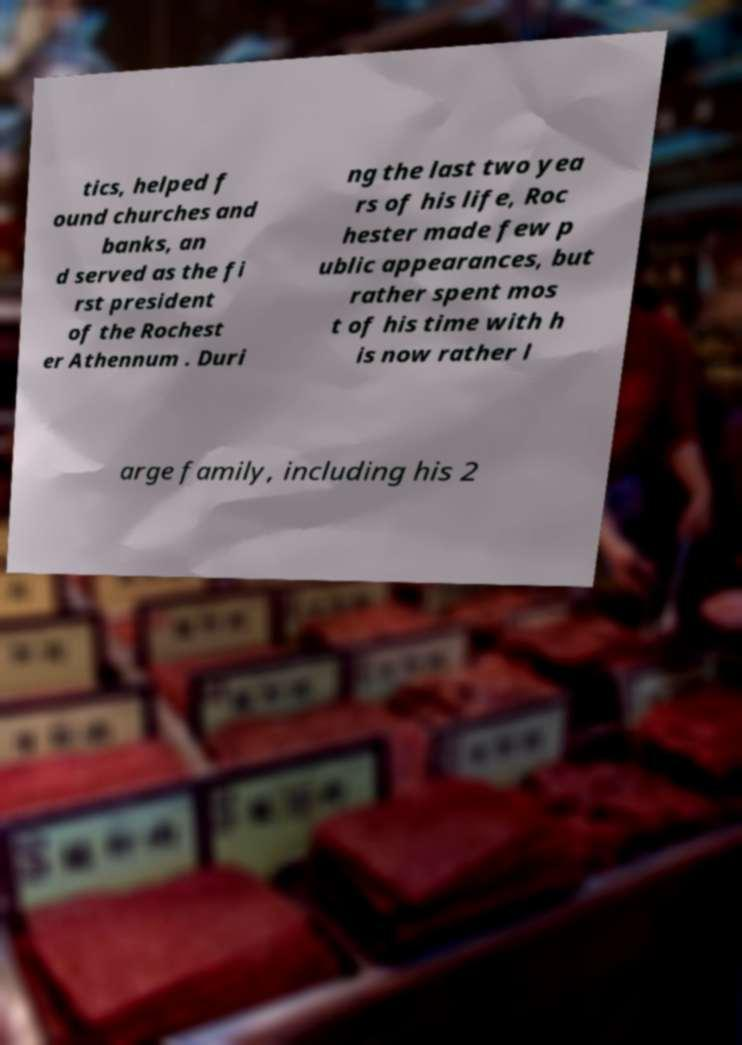Could you extract and type out the text from this image? tics, helped f ound churches and banks, an d served as the fi rst president of the Rochest er Athennum . Duri ng the last two yea rs of his life, Roc hester made few p ublic appearances, but rather spent mos t of his time with h is now rather l arge family, including his 2 